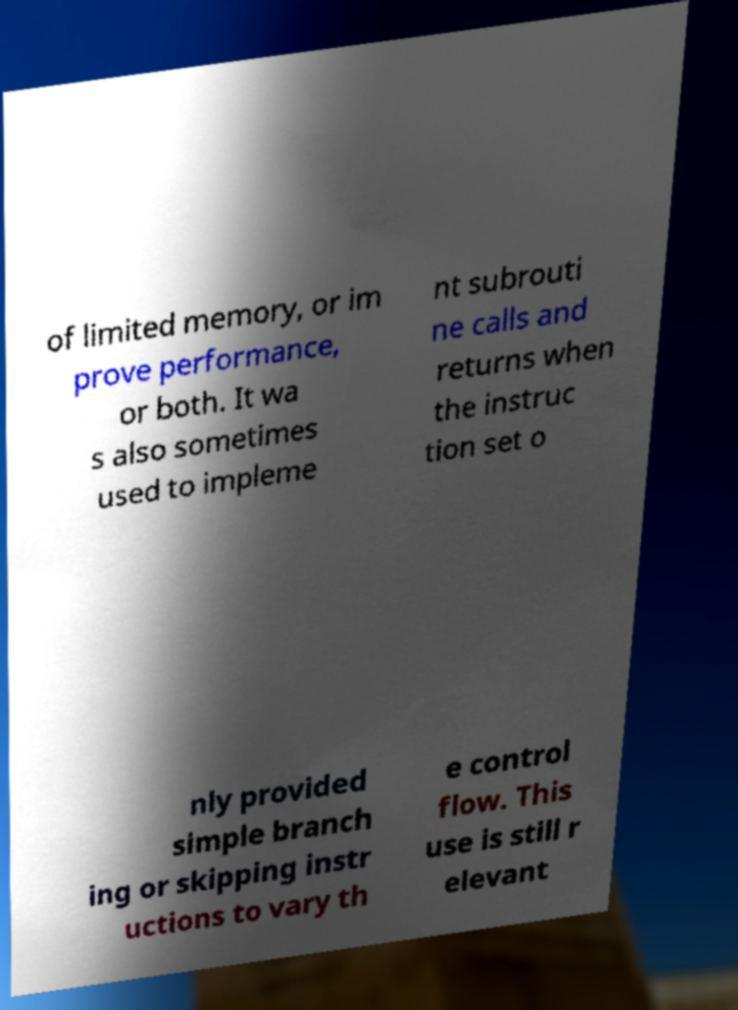Please read and relay the text visible in this image. What does it say? of limited memory, or im prove performance, or both. It wa s also sometimes used to impleme nt subrouti ne calls and returns when the instruc tion set o nly provided simple branch ing or skipping instr uctions to vary th e control flow. This use is still r elevant 